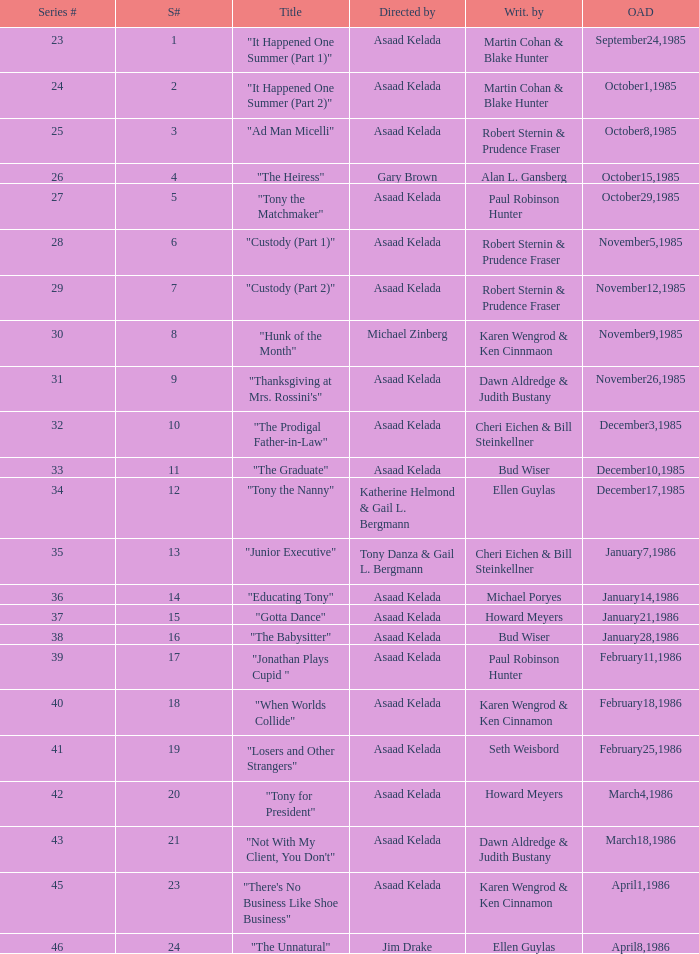What season features writer Michael Poryes? 14.0. 